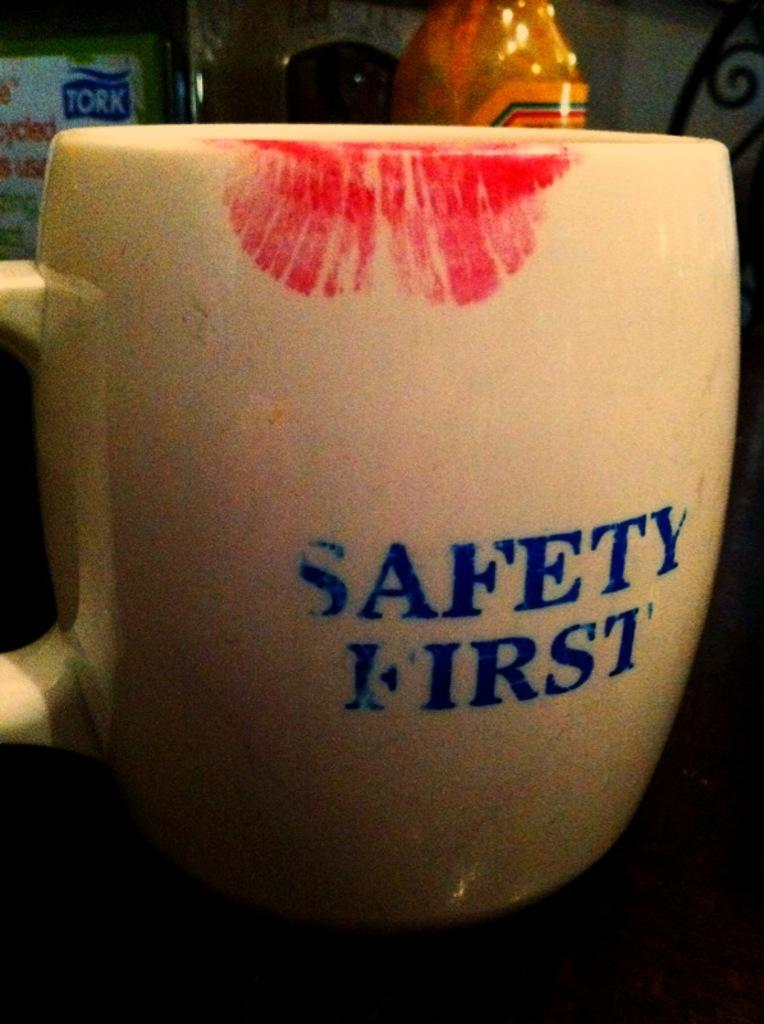<image>
Present a compact description of the photo's key features. Cup with a lipstick stain that says Safety First. 